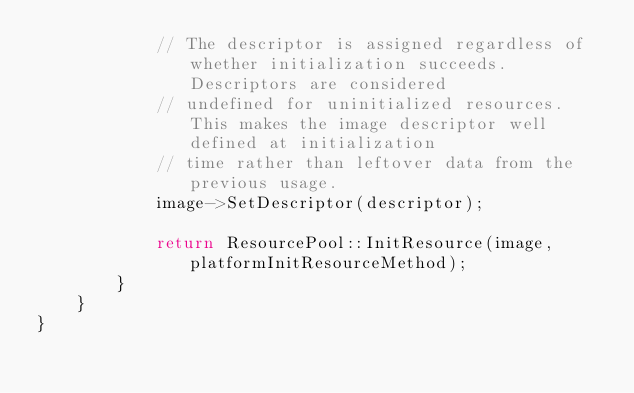Convert code to text. <code><loc_0><loc_0><loc_500><loc_500><_C++_>            // The descriptor is assigned regardless of whether initialization succeeds. Descriptors are considered
            // undefined for uninitialized resources. This makes the image descriptor well defined at initialization
            // time rather than leftover data from the previous usage.             
            image->SetDescriptor(descriptor);
            
            return ResourcePool::InitResource(image, platformInitResourceMethod);
        }
    }
}
</code> 